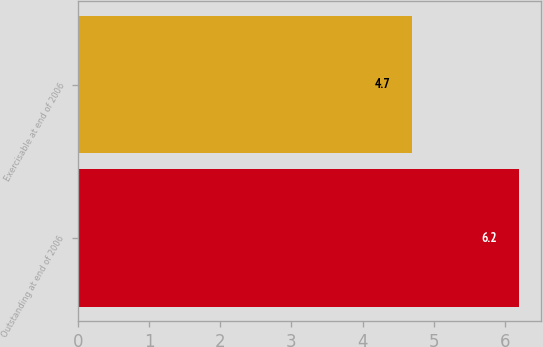Convert chart. <chart><loc_0><loc_0><loc_500><loc_500><bar_chart><fcel>Outstanding at end of 2006<fcel>Exercisable at end of 2006<nl><fcel>6.2<fcel>4.7<nl></chart> 